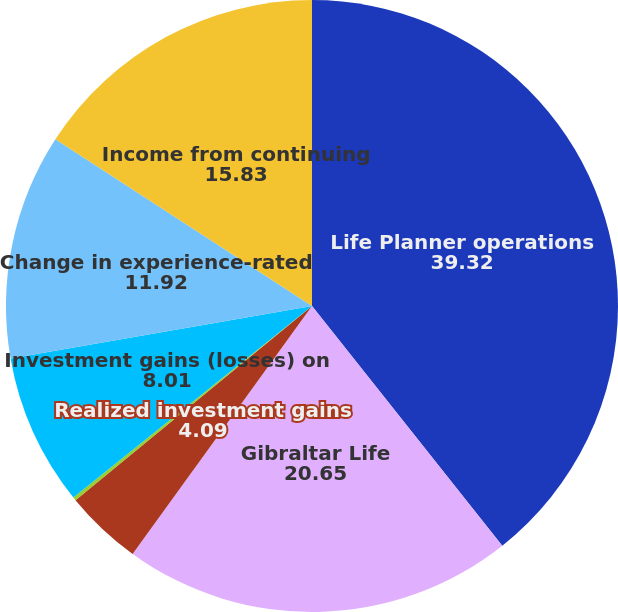<chart> <loc_0><loc_0><loc_500><loc_500><pie_chart><fcel>Life Planner operations<fcel>Gibraltar Life<fcel>Realized investment gains<fcel>Related charges(2)<fcel>Investment gains (losses) on<fcel>Change in experience-rated<fcel>Income from continuing<nl><fcel>39.32%<fcel>20.65%<fcel>4.09%<fcel>0.18%<fcel>8.01%<fcel>11.92%<fcel>15.83%<nl></chart> 